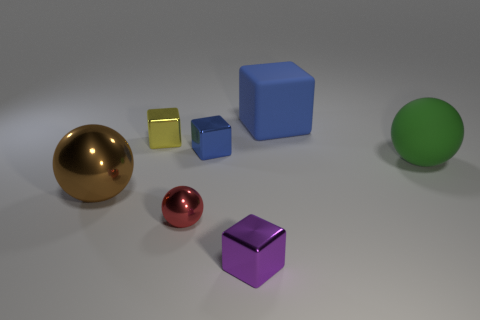Does the blue object that is behind the blue metallic block have the same shape as the tiny object in front of the tiny metal ball?
Offer a terse response. Yes. The large matte ball has what color?
Your answer should be compact. Green. How many metallic objects are small brown blocks or large blue cubes?
Keep it short and to the point. 0. There is another rubber object that is the same shape as the tiny blue thing; what is its color?
Ensure brevity in your answer.  Blue. Are there any tiny blue metal cylinders?
Your response must be concise. No. Is the small block in front of the large brown sphere made of the same material as the blue thing that is in front of the big blue block?
Give a very brief answer. Yes. There is a metal object that is the same color as the large rubber cube; what shape is it?
Offer a terse response. Cube. How many objects are things that are behind the tiny purple metallic object or cubes in front of the large brown ball?
Your answer should be very brief. 7. Is the color of the large sphere that is left of the large green thing the same as the large rubber object that is to the right of the large rubber block?
Your answer should be very brief. No. There is a object that is both left of the red thing and behind the tiny blue shiny object; what shape is it?
Give a very brief answer. Cube. 